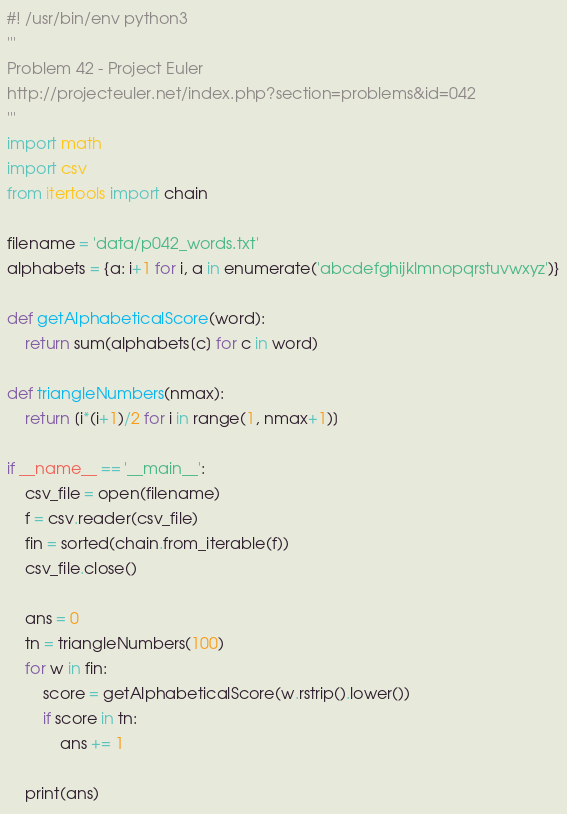<code> <loc_0><loc_0><loc_500><loc_500><_Python_>#! /usr/bin/env python3
'''
Problem 42 - Project Euler
http://projecteuler.net/index.php?section=problems&id=042
'''
import math
import csv
from itertools import chain

filename = 'data/p042_words.txt'
alphabets = {a: i+1 for i, a in enumerate('abcdefghijklmnopqrstuvwxyz')}

def getAlphabeticalScore(word):
    return sum(alphabets[c] for c in word)

def triangleNumbers(nmax):
    return [i*(i+1)/2 for i in range(1, nmax+1)]

if __name__ == '__main__':
    csv_file = open(filename)
    f = csv.reader(csv_file)
    fin = sorted(chain.from_iterable(f))
    csv_file.close()

    ans = 0
    tn = triangleNumbers(100)
    for w in fin:
        score = getAlphabeticalScore(w.rstrip().lower())
        if score in tn:
            ans += 1

    print(ans)
</code> 